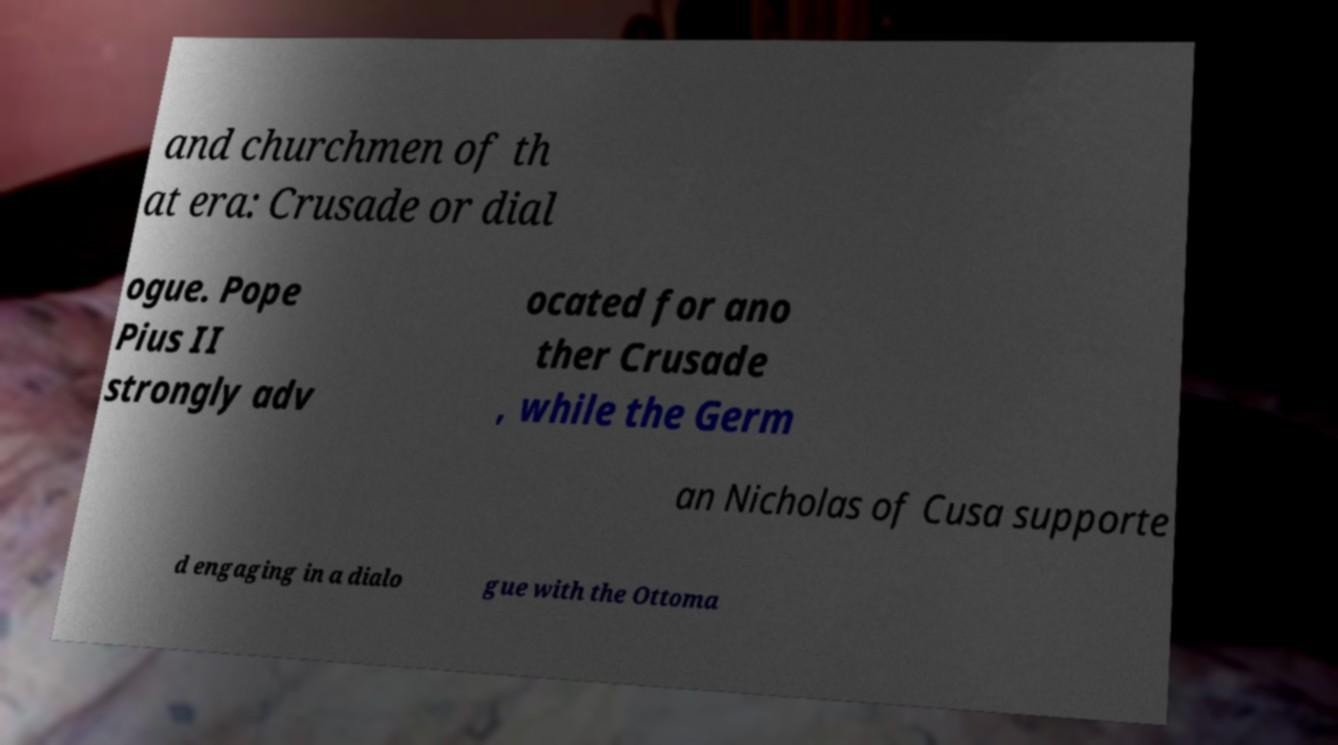Can you read and provide the text displayed in the image?This photo seems to have some interesting text. Can you extract and type it out for me? and churchmen of th at era: Crusade or dial ogue. Pope Pius II strongly adv ocated for ano ther Crusade , while the Germ an Nicholas of Cusa supporte d engaging in a dialo gue with the Ottoma 